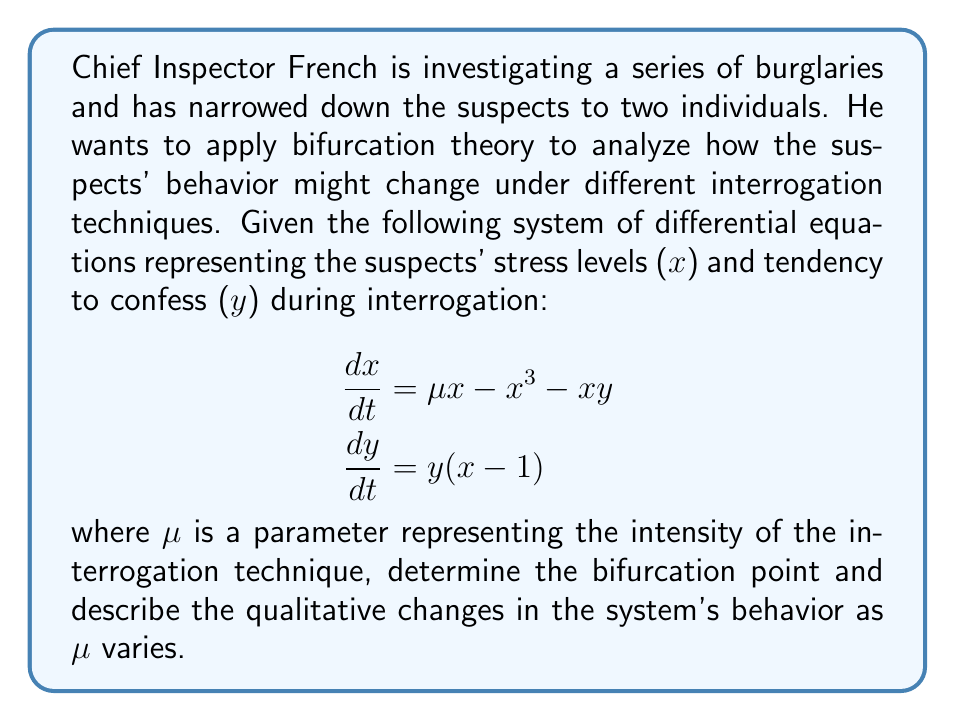Can you answer this question? To solve this problem, we'll follow Chief Inspector French's methodical approach:

1) First, we need to find the equilibrium points of the system. Set both equations to zero:

   $$\begin{aligned}
   \mu x - x^3 - xy &= 0 \\
   y(x - 1) &= 0
   \end{aligned}$$

2) From the second equation, we can see that either $y = 0$ or $x = 1$. Let's consider both cases:

   Case 1: If $y = 0$, then from the first equation:
   $$\mu x - x^3 = 0$$
   $$x(\mu - x^2) = 0$$
   So, $x = 0$ or $x = \pm\sqrt{\mu}$ (when $\mu > 0$)

   Case 2: If $x = 1$, then from the first equation:
   $$\mu - 1 - y = 0$$
   $$y = \mu - 1$$

3) Now, we have three equilibrium points:
   - $(0, 0)$ for all $\mu$
   - $(\pm\sqrt{\mu}, 0)$ when $\mu > 0$
   - $(1, \mu - 1)$ when $\mu > 1$

4) The bifurcation occurs when the stability of these equilibrium points changes. Let's analyze the stability of $(0, 0)$:

   The Jacobian matrix at $(0, 0)$ is:
   $$J = \begin{bmatrix}
   \mu & 0 \\
   0 & -1
   \end{bmatrix}$$

   The eigenvalues are $\mu$ and $-1$. The stability changes when $\mu = 0$.

5) When $\mu < 0$, $(0, 0)$ is stable. When $\mu > 0$, $(0, 0)$ becomes unstable, and two new stable equilibrium points $(\pm\sqrt{\mu}, 0)$ appear.

6) This bifurcation at $\mu = 0$ is known as a pitchfork bifurcation, which is common in systems with symmetry.

7) Another bifurcation occurs at $\mu = 1$, where the equilibrium point $(1, \mu - 1)$ becomes physically meaningful (as $y$ becomes non-negative).

In the context of the investigation, this means:
- For low interrogation intensity ($\mu < 0$), suspects tend to remain calm and silent.
- As intensity increases ($\mu > 0$), suspects may show stress but still not confess.
- At higher intensities ($\mu > 1$), some suspects may start to confess.
Answer: Pitchfork bifurcation at $\mu = 0$; transcritical bifurcation at $\mu = 1$. 